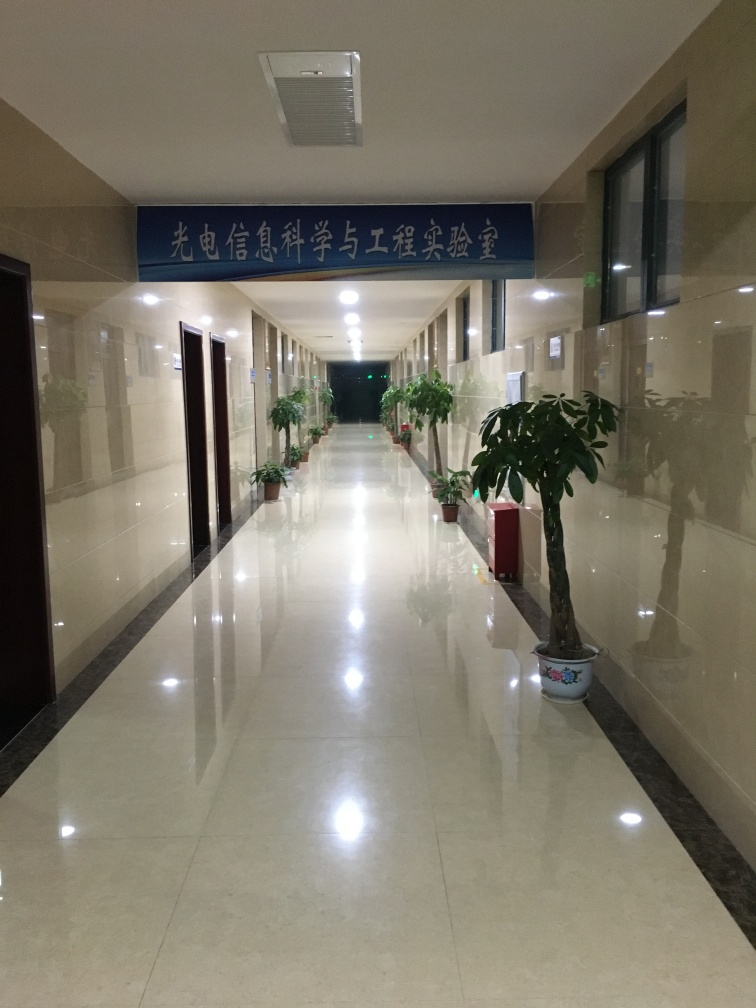How would you describe the mood or atmosphere conveyed by this image? The image conveys a sense of stillness and quietness, possibly due to the absence of people and the symmetrical perspective of the hallway. The artificial lighting enhances the feeling of an indoor, controlled environment with a formal, perhaps official, ambiance. 